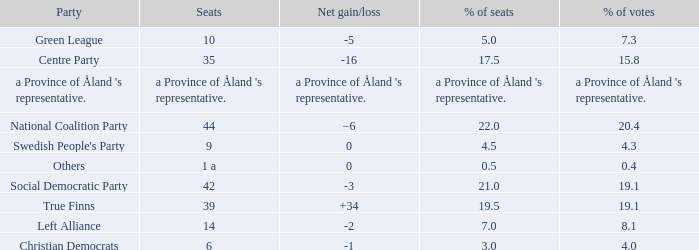Regarding the seats that casted 8.1% of the vote how many seats were held? 14.0. 